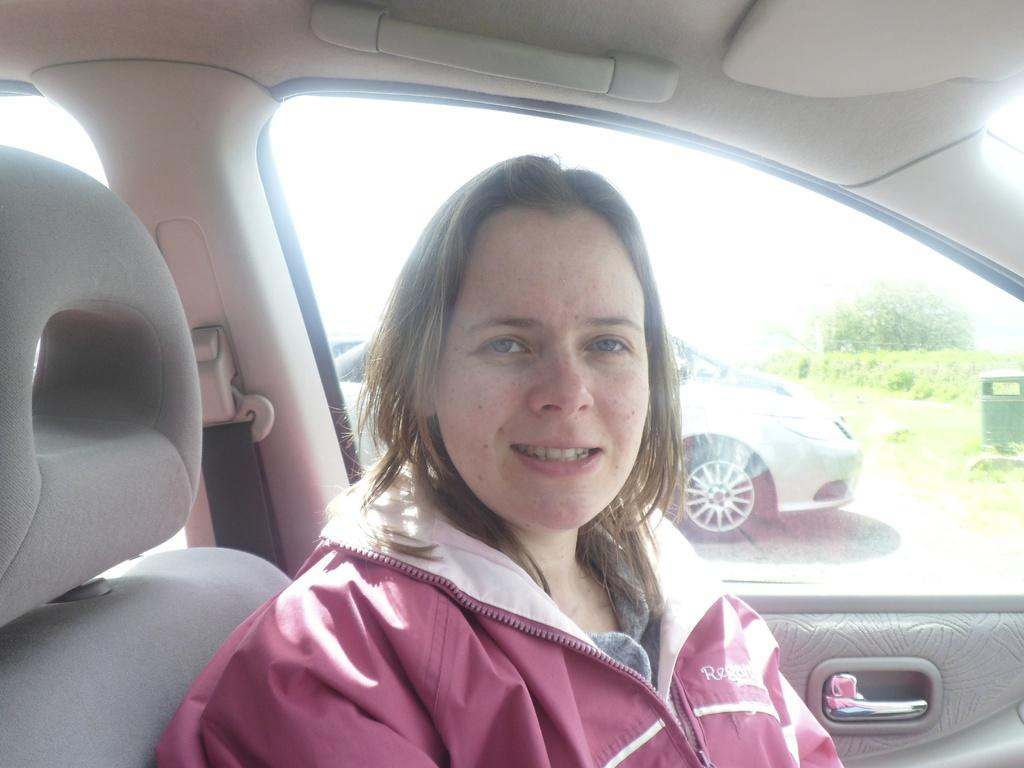Who is present in the image? There is a woman in the image. What is the woman doing in the image? The woman is sitting in a seat. Where is the woman located in the image? The woman is inside a car. What can be seen in the background of the image? There is another car and trees visible in the background of the image. What type of button is the woman wearing on her shirt in the image? There is no button visible on the woman's shirt in the image. What company is responsible for manufacturing the car the woman is sitting in? The provided facts do not mention the make or model of the car, so it is not possible to determine the manufacturer. 